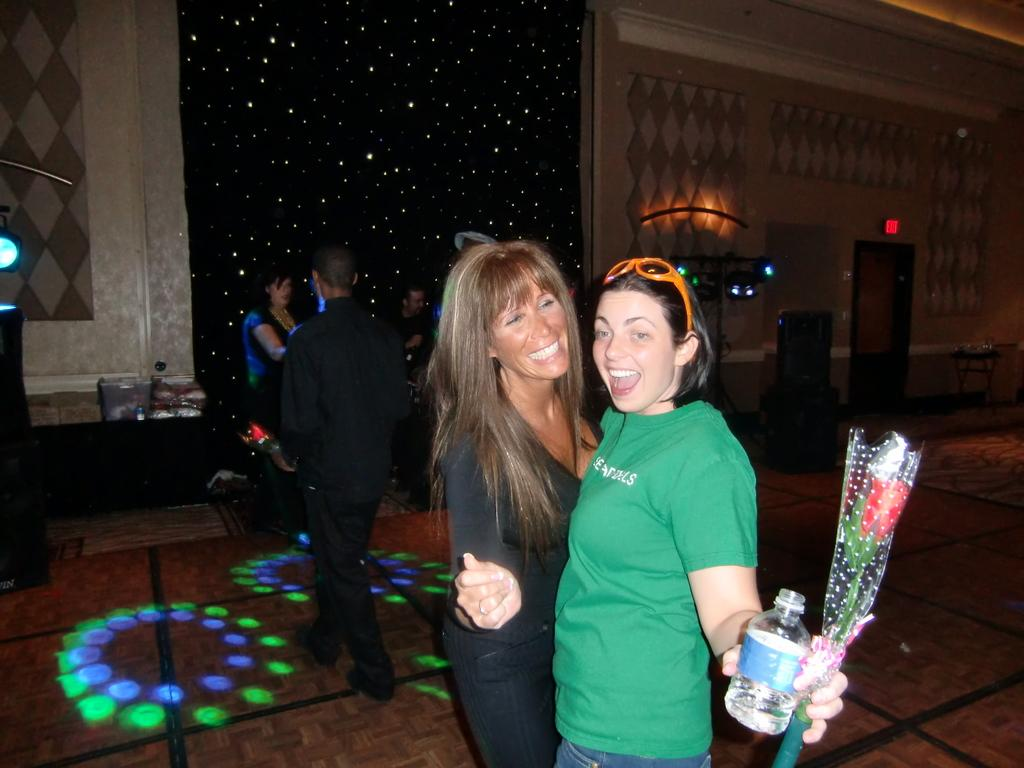Who or what is present in the image? There are people in the image. What is the background of the image? There is a wall in the image. What can be seen illuminating the scene? There are lights in the image. What object is visible in the image that might contain a liquid? There is a bottle in the image. What type of decorative item can be seen in the image? There is a bouquet in the image. What type of pipe is being used by the people in the image? There is no pipe present in the image. What role do the parents play in the image? The concept of parents is not mentioned or depicted in the image. 